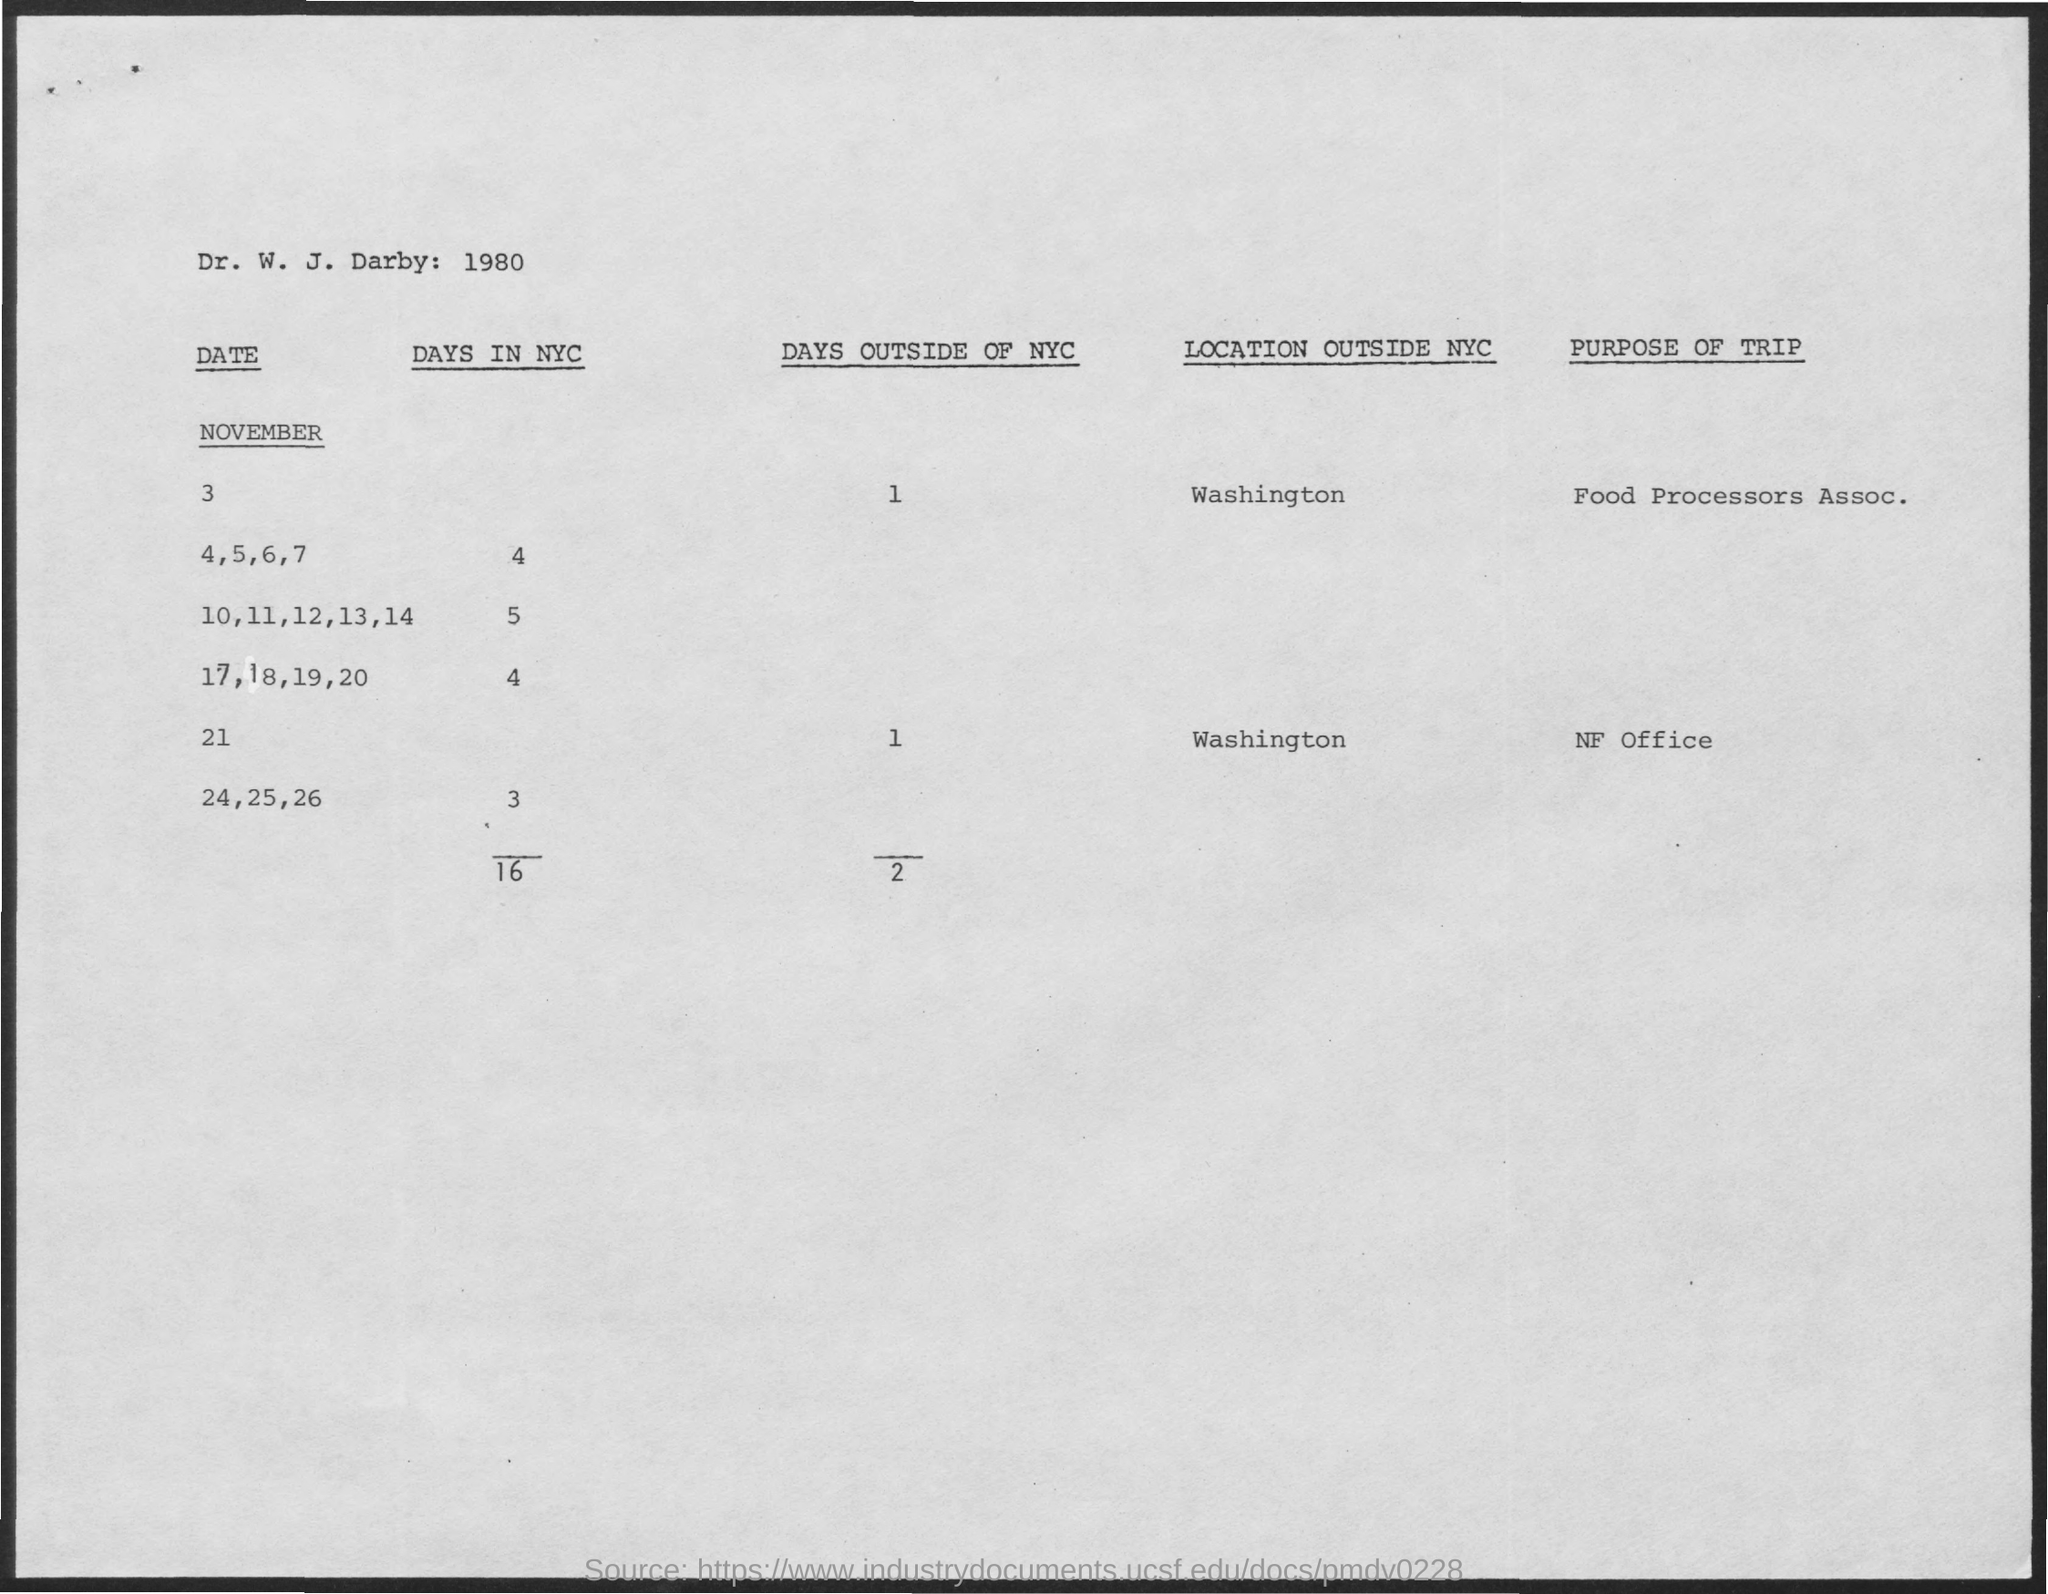What is the number of Days in NYC for November 4,5,6,7?
Ensure brevity in your answer.  4. What is the number of Days in NYC for November 10,11,12,13,14?
Offer a terse response. 5. What is the number of Days in NYC for November 17,18,19,20?
Offer a terse response. 4. What is the number of Days in NYC for November 24,25,26?
Provide a succinct answer. 3. What is the number of Days outside of NYC for November 3?
Your response must be concise. 1. What is the number of Days outside of NYC for November 21?
Provide a short and direct response. 1. What is the Location outside of NYC in November 3?
Your answer should be very brief. Washington. What is the Location outside of NYC in November 21?
Your answer should be very brief. Washington. What is the Purpose of trip for November 3?
Ensure brevity in your answer.  Food processors assoc. What is the Purpose of trip for November 21?
Your answer should be very brief. Nf office. 